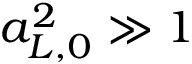Convert formula to latex. <formula><loc_0><loc_0><loc_500><loc_500>a _ { L , 0 } ^ { 2 } \gg 1</formula> 